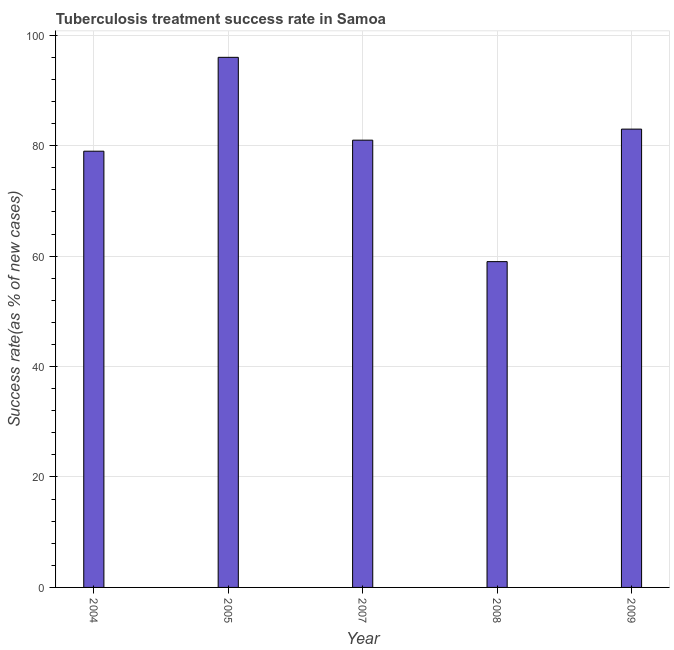Does the graph contain any zero values?
Offer a terse response. No. What is the title of the graph?
Keep it short and to the point. Tuberculosis treatment success rate in Samoa. What is the label or title of the X-axis?
Offer a very short reply. Year. What is the label or title of the Y-axis?
Your response must be concise. Success rate(as % of new cases). What is the tuberculosis treatment success rate in 2007?
Offer a terse response. 81. Across all years, what is the maximum tuberculosis treatment success rate?
Offer a very short reply. 96. Across all years, what is the minimum tuberculosis treatment success rate?
Make the answer very short. 59. In which year was the tuberculosis treatment success rate minimum?
Keep it short and to the point. 2008. What is the sum of the tuberculosis treatment success rate?
Give a very brief answer. 398. What is the difference between the tuberculosis treatment success rate in 2005 and 2007?
Ensure brevity in your answer.  15. What is the average tuberculosis treatment success rate per year?
Make the answer very short. 79. Do a majority of the years between 2008 and 2009 (inclusive) have tuberculosis treatment success rate greater than 8 %?
Keep it short and to the point. Yes. What is the ratio of the tuberculosis treatment success rate in 2005 to that in 2009?
Offer a terse response. 1.16. Is the difference between the tuberculosis treatment success rate in 2008 and 2009 greater than the difference between any two years?
Make the answer very short. No. Is the sum of the tuberculosis treatment success rate in 2007 and 2009 greater than the maximum tuberculosis treatment success rate across all years?
Offer a terse response. Yes. In how many years, is the tuberculosis treatment success rate greater than the average tuberculosis treatment success rate taken over all years?
Offer a very short reply. 3. Are all the bars in the graph horizontal?
Offer a terse response. No. How many years are there in the graph?
Provide a succinct answer. 5. Are the values on the major ticks of Y-axis written in scientific E-notation?
Give a very brief answer. No. What is the Success rate(as % of new cases) of 2004?
Your response must be concise. 79. What is the Success rate(as % of new cases) in 2005?
Provide a short and direct response. 96. What is the Success rate(as % of new cases) in 2009?
Offer a terse response. 83. What is the difference between the Success rate(as % of new cases) in 2004 and 2005?
Your response must be concise. -17. What is the difference between the Success rate(as % of new cases) in 2004 and 2007?
Your answer should be very brief. -2. What is the difference between the Success rate(as % of new cases) in 2005 and 2009?
Give a very brief answer. 13. What is the difference between the Success rate(as % of new cases) in 2007 and 2008?
Make the answer very short. 22. What is the difference between the Success rate(as % of new cases) in 2008 and 2009?
Give a very brief answer. -24. What is the ratio of the Success rate(as % of new cases) in 2004 to that in 2005?
Your answer should be compact. 0.82. What is the ratio of the Success rate(as % of new cases) in 2004 to that in 2007?
Offer a terse response. 0.97. What is the ratio of the Success rate(as % of new cases) in 2004 to that in 2008?
Provide a short and direct response. 1.34. What is the ratio of the Success rate(as % of new cases) in 2005 to that in 2007?
Ensure brevity in your answer.  1.19. What is the ratio of the Success rate(as % of new cases) in 2005 to that in 2008?
Offer a very short reply. 1.63. What is the ratio of the Success rate(as % of new cases) in 2005 to that in 2009?
Offer a terse response. 1.16. What is the ratio of the Success rate(as % of new cases) in 2007 to that in 2008?
Keep it short and to the point. 1.37. What is the ratio of the Success rate(as % of new cases) in 2008 to that in 2009?
Ensure brevity in your answer.  0.71. 